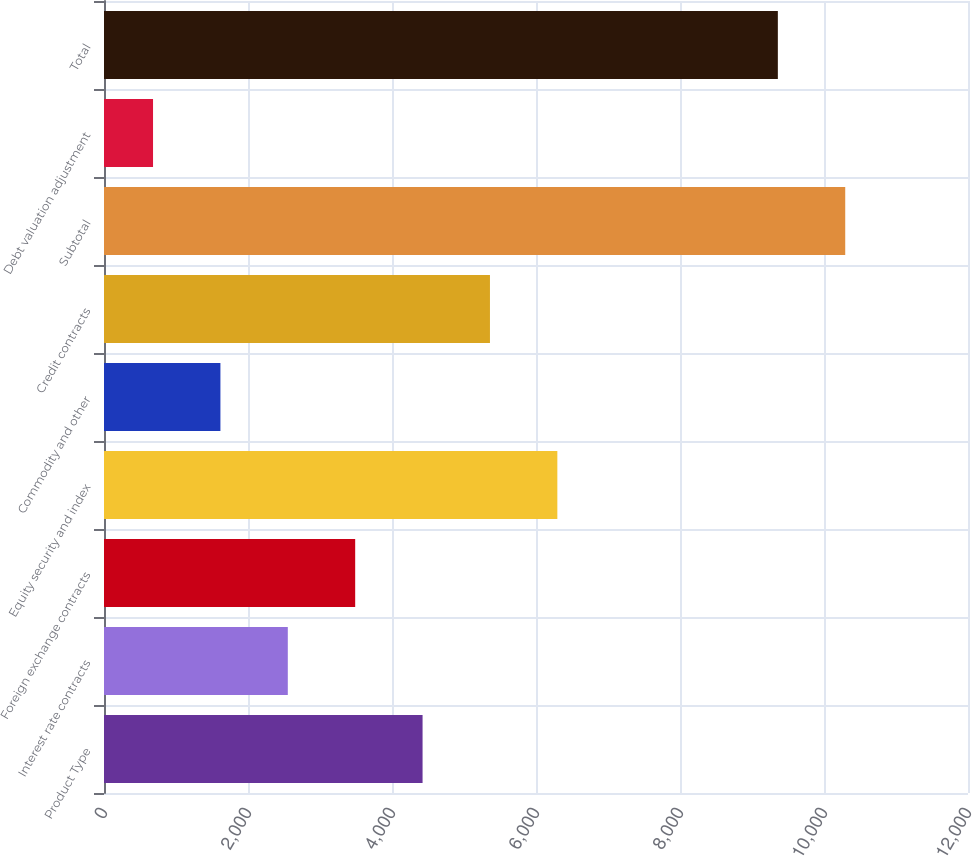<chart> <loc_0><loc_0><loc_500><loc_500><bar_chart><fcel>Product Type<fcel>Interest rate contracts<fcel>Foreign exchange contracts<fcel>Equity security and index<fcel>Commodity and other<fcel>Credit contracts<fcel>Subtotal<fcel>Debt valuation adjustment<fcel>Total<nl><fcel>4424.6<fcel>2552.8<fcel>3488.7<fcel>6296.4<fcel>1616.9<fcel>5360.5<fcel>10294.9<fcel>681<fcel>9359<nl></chart> 